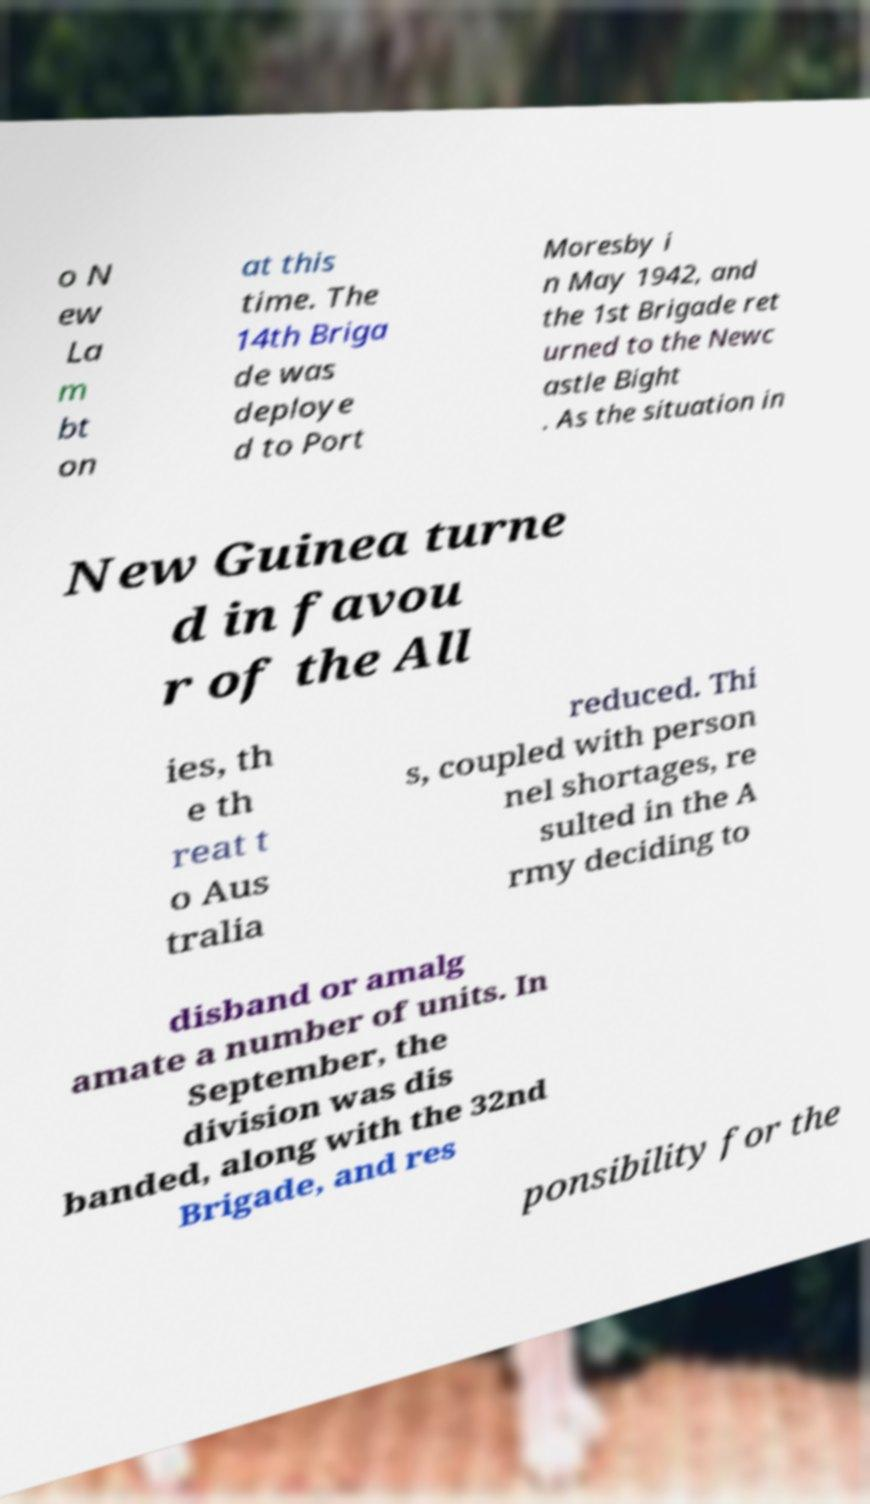Could you assist in decoding the text presented in this image and type it out clearly? o N ew La m bt on at this time. The 14th Briga de was deploye d to Port Moresby i n May 1942, and the 1st Brigade ret urned to the Newc astle Bight . As the situation in New Guinea turne d in favou r of the All ies, th e th reat t o Aus tralia reduced. Thi s, coupled with person nel shortages, re sulted in the A rmy deciding to disband or amalg amate a number of units. In September, the division was dis banded, along with the 32nd Brigade, and res ponsibility for the 